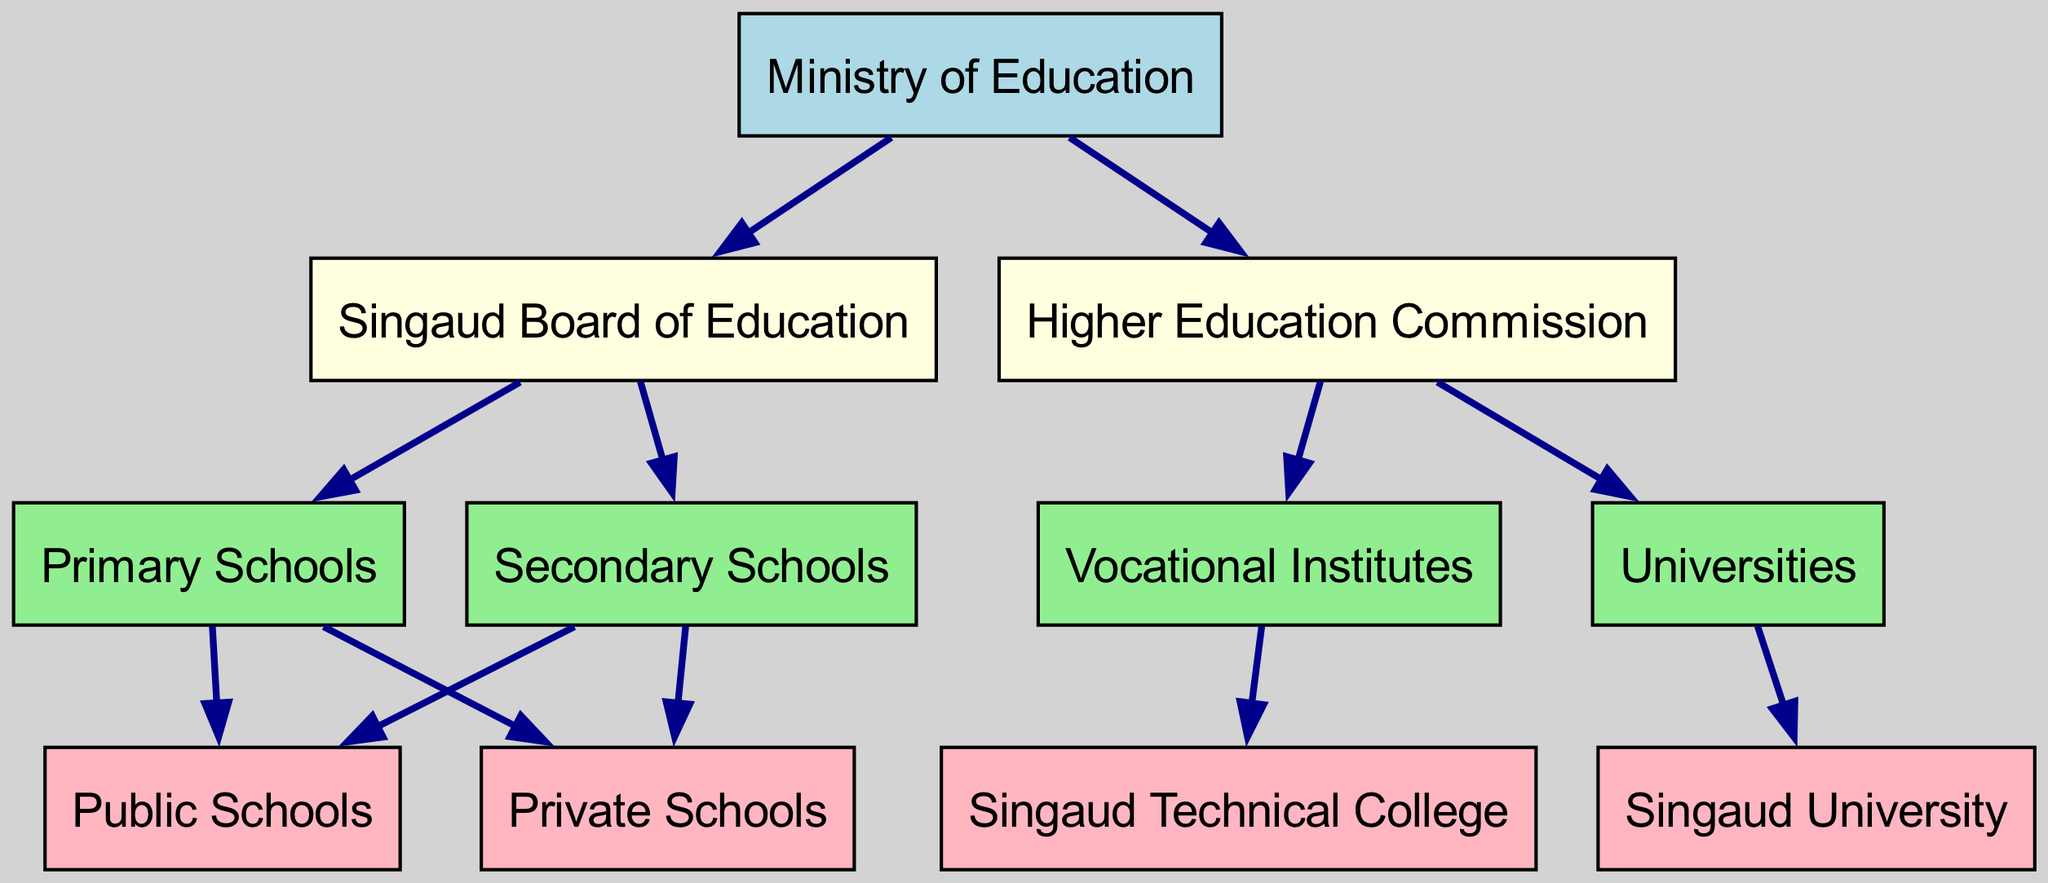What is the top level of the educational system hierarchy? The top level in the diagram is indicated as "Ministry of Education." It is visually positioned at the topmost part of the diagram, contrasting with other levels below it.
Answer: Ministry of Education How many second-level entities are there? There are two second-level entities in the diagram, which are "Singaud Board of Education" and "Higher Education Commission." I counted them within the second level section of the block diagram.
Answer: 2 Which entity connects directly to "Higher Education Commission"? The "Vocational Institutes" and "Universities" connect directly to "Higher Education Commission." This is shown through the arrows leading from the Higher Education Commission to these entities in the diagram.
Answer: Vocational Institutes, Universities What is the relationship between "Primary Schools" and "Public Schools"? The relationship is that "Primary Schools" leads to "Public Schools" in the diagram. This connection is shown with a directed edge from "Primary Schools" to "Public Schools," indicating that public schools fall under primary schools' category.
Answer: Public Schools What color represents the top-level node? The top-level node "Ministry of Education" is filled with the color light blue in the diagram. This color is distinct from the colors of lower-level nodes, helping to identify it quickly.
Answer: Light blue How many types of schools are under the "Primary Schools" category? There are two types of schools under the "Primary Schools" category, which are "Public Schools" and "Private Schools." This is confirmed by counting the nodes connected to "Primary Schools" labeled in the diagram.
Answer: 2 Which entity is a direct subcategory of "Vocational Institutes"? The "Singaud Technical College" is a direct subcategory of "Vocational Institutes." The diagram illustrates this connection with a directed edge leading from "Vocational Institutes" to "Singaud Technical College."
Answer: Singaud Technical College What is the total number of nodes at the fourth level? There are four nodes at the fourth level: "Public Schools," "Private Schools," "Singaud Technical College," and "Singaud University." Counting these nodes in the fourth level section of the diagram gives the total.
Answer: 4 